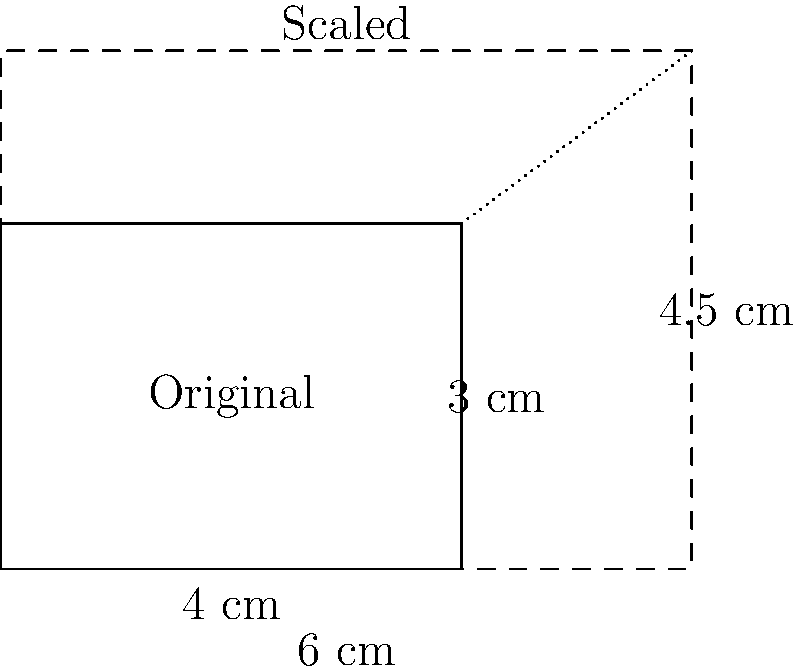You're redesigning your menu layout and need to scale up the icons for menu items. The original icon size is 4 cm by 3 cm, and you want to increase the width to 6 cm while maintaining the aspect ratio. What will be the new height of the scaled icon? To solve this problem, we'll use the concept of scaling and aspect ratio preservation:

1) First, let's identify the scale factor for the width:
   New width / Original width = $6 \text{ cm} / 4 \text{ cm} = 1.5$

2) To maintain the aspect ratio, we must apply the same scale factor to the height:
   New height = Original height $\times$ Scale factor
   New height = $3 \text{ cm} \times 1.5$

3) Calculate the new height:
   New height = $3 \text{ cm} \times 1.5 = 4.5 \text{ cm}$

4) Verify the aspect ratio:
   Original aspect ratio: $4:3$
   New aspect ratio: $6:4.5 = 4:3$ (when simplified)

Therefore, the new height of the scaled icon will be 4.5 cm, maintaining the original aspect ratio.
Answer: 4.5 cm 